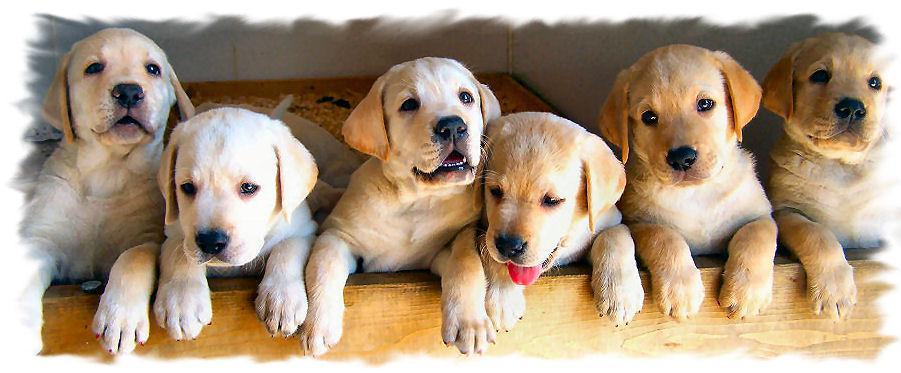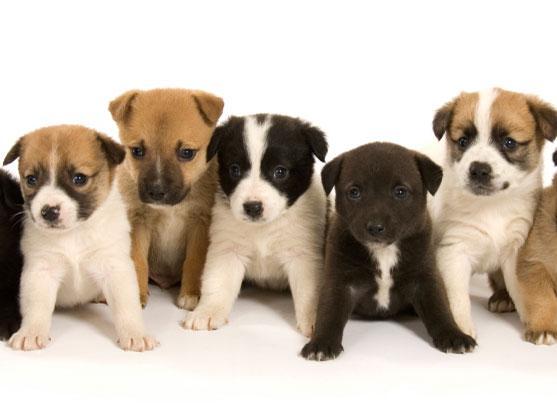The first image is the image on the left, the second image is the image on the right. Considering the images on both sides, is "One of the images in the pair contains at least ten dogs." valid? Answer yes or no. No. 